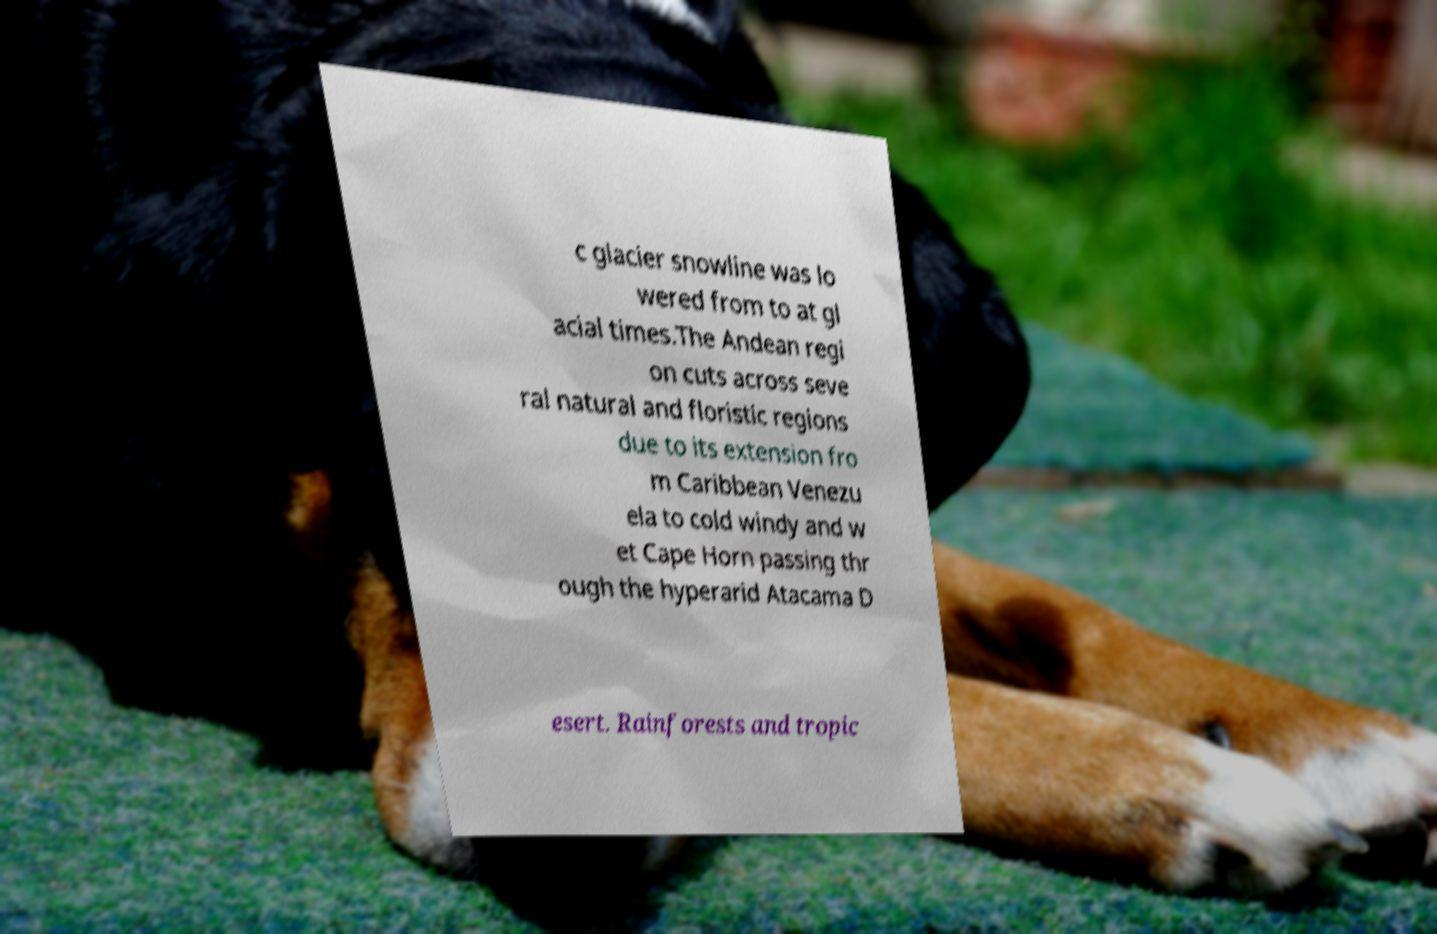What messages or text are displayed in this image? I need them in a readable, typed format. c glacier snowline was lo wered from to at gl acial times.The Andean regi on cuts across seve ral natural and floristic regions due to its extension fro m Caribbean Venezu ela to cold windy and w et Cape Horn passing thr ough the hyperarid Atacama D esert. Rainforests and tropic 